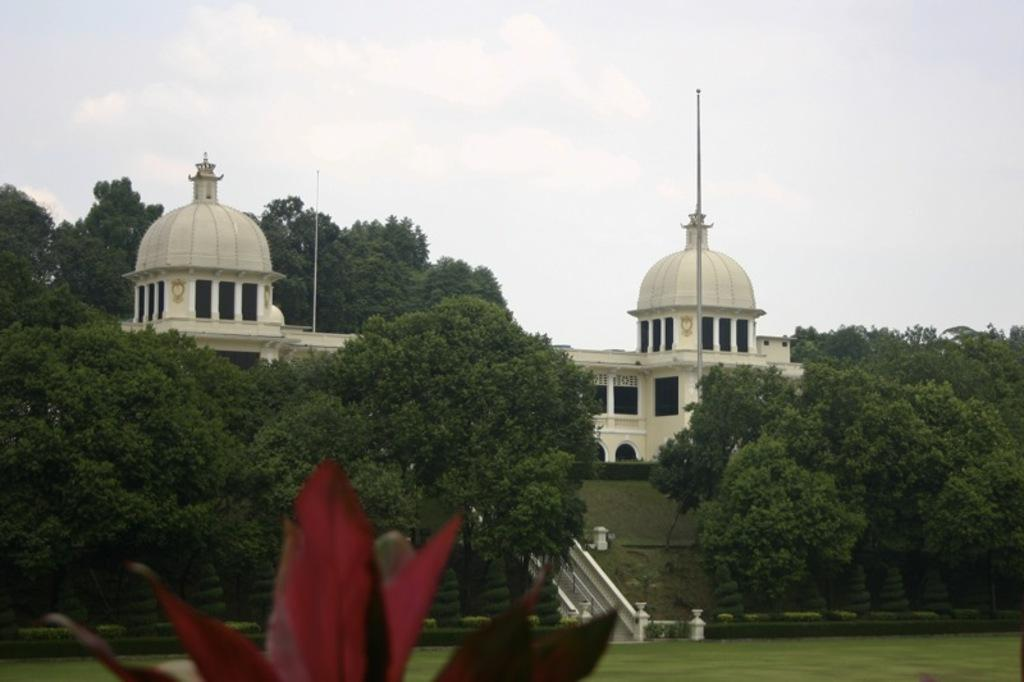How many buildings can be seen in the image? There are 2 buildings in the image. What type of vegetation is present in the image? Trees, grass, and plants are present in the image. Can you describe any architectural features in the image? There is a staircase in the image. What else can be seen in the image besides the buildings and vegetation? Poles are present in the image. How would you describe the weather in the image? The sky is cloudy in the image. What type of horse is being ridden by the writer in the image? There is no horse or writer present in the image. What is the writer doing with the box in the image? There is no writer or box present in the image. 